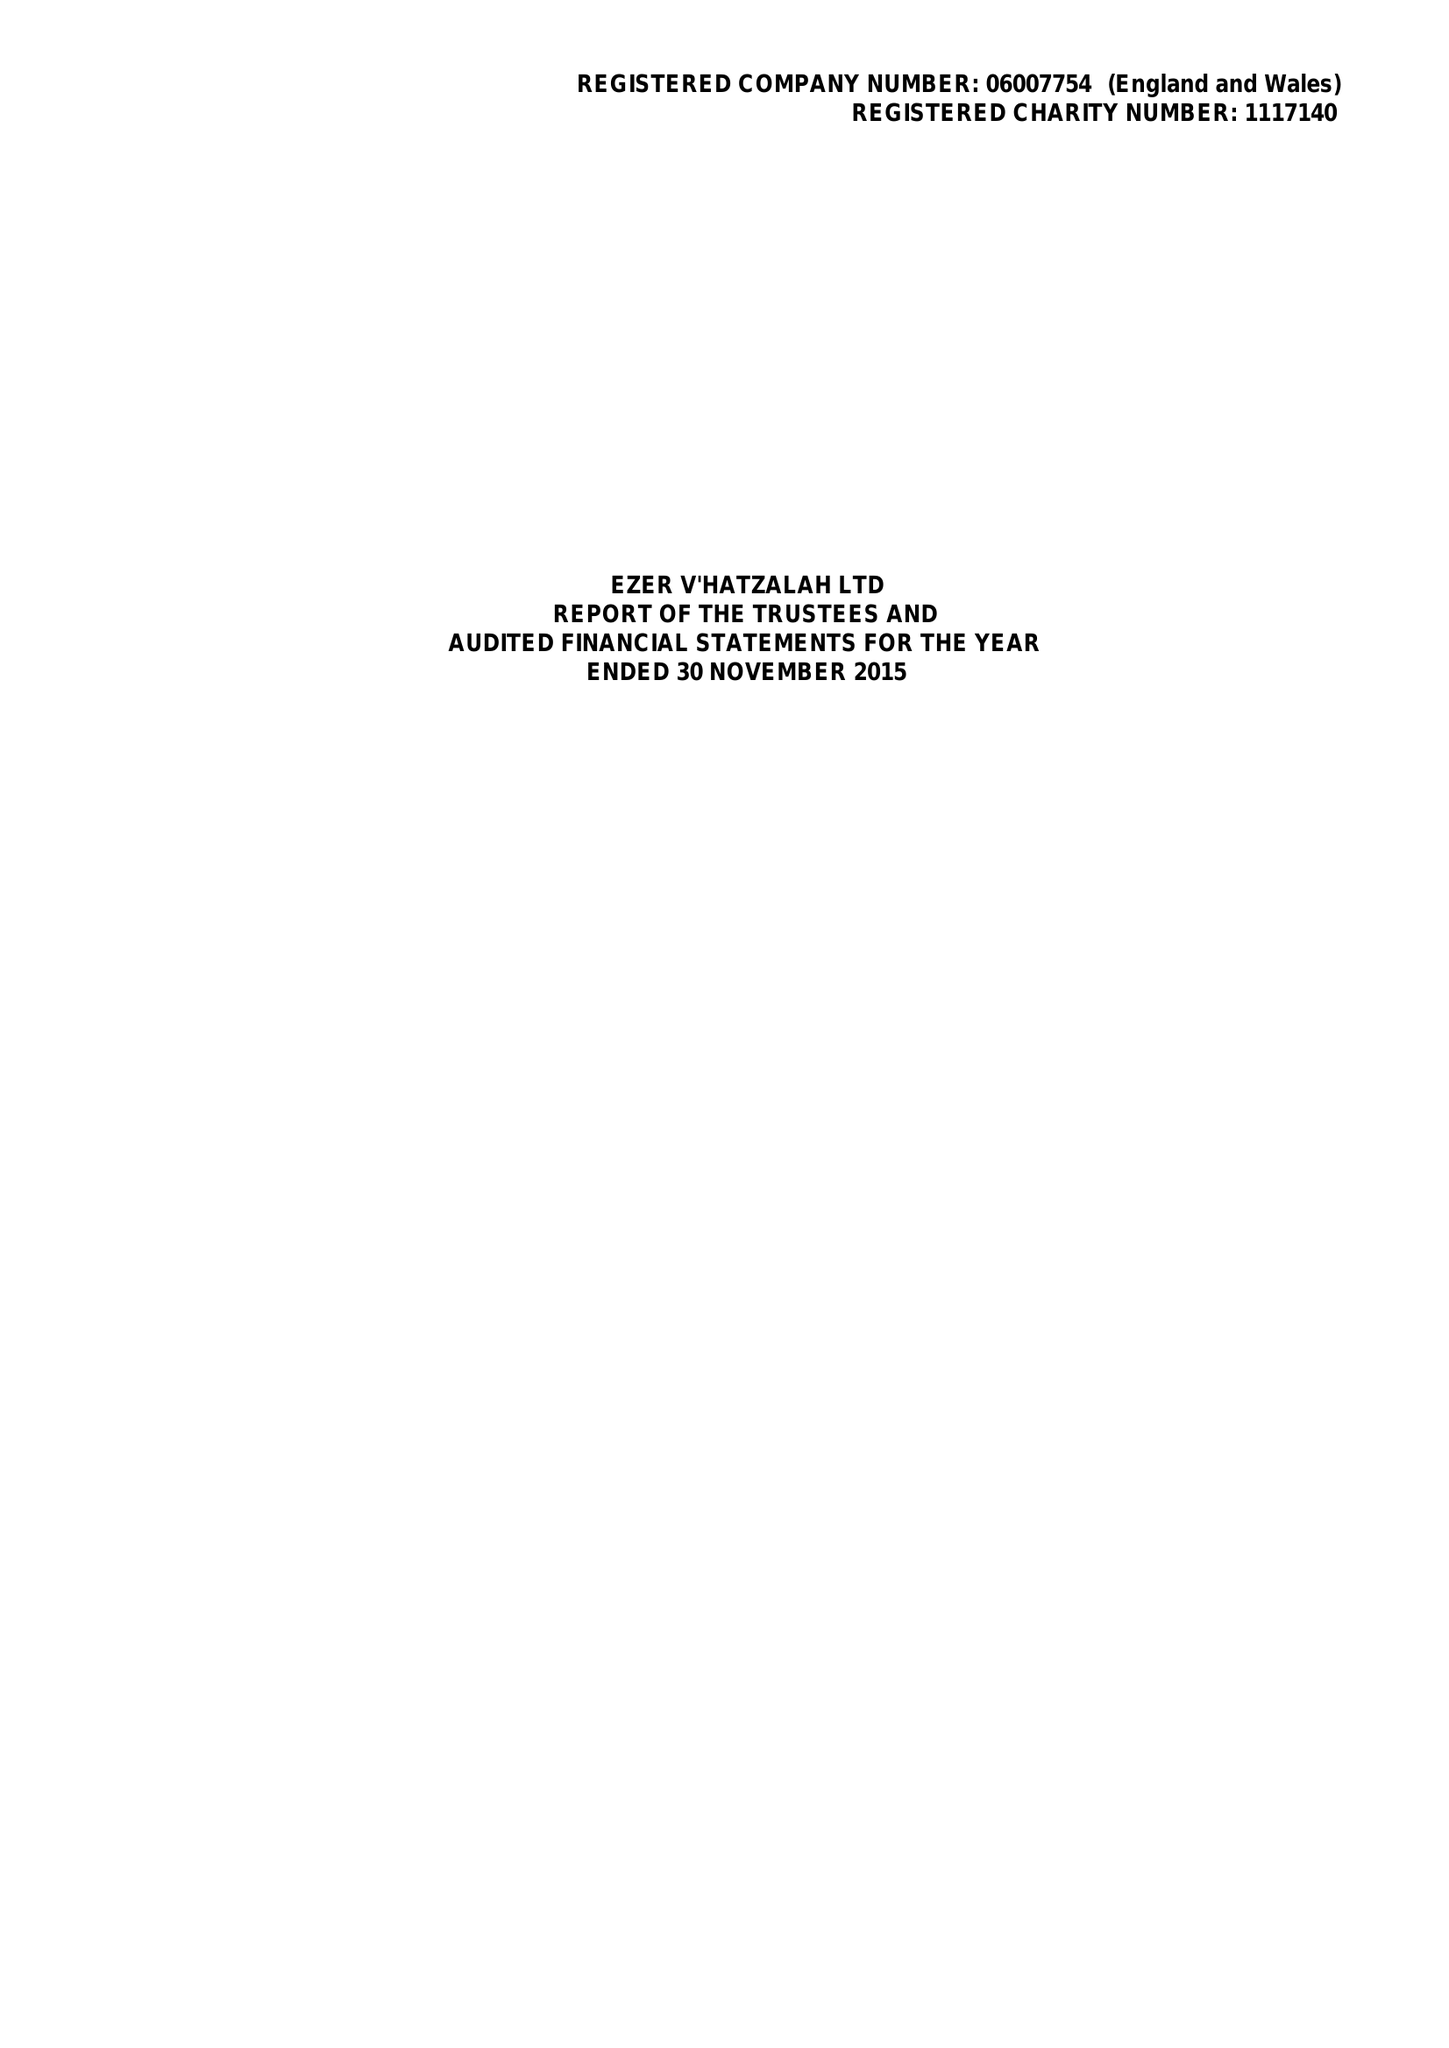What is the value for the charity_number?
Answer the question using a single word or phrase. 1117140 